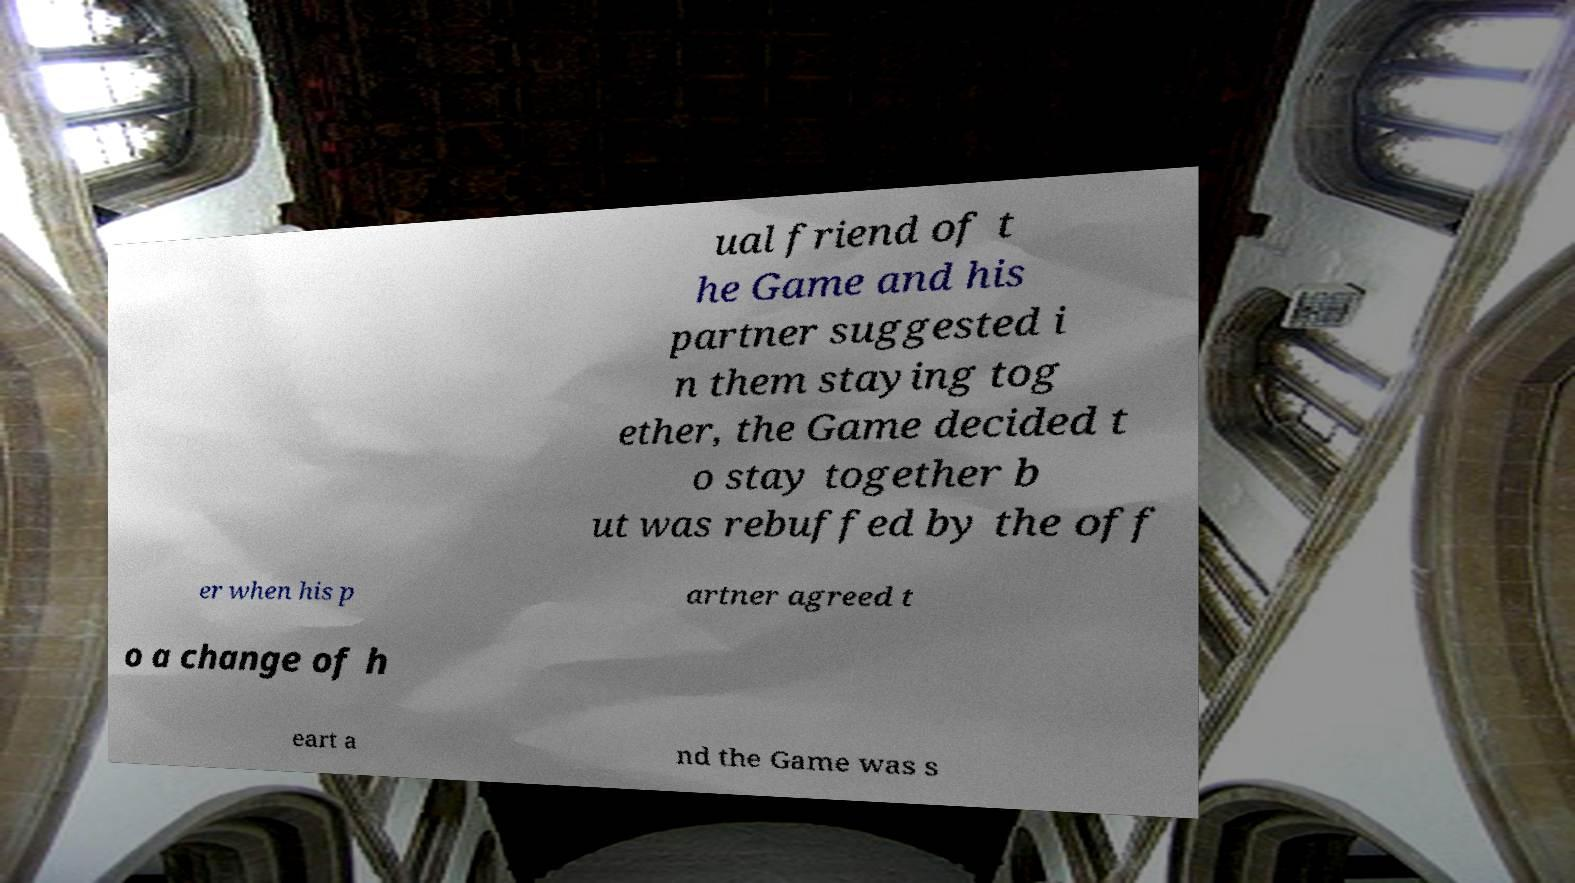For documentation purposes, I need the text within this image transcribed. Could you provide that? ual friend of t he Game and his partner suggested i n them staying tog ether, the Game decided t o stay together b ut was rebuffed by the off er when his p artner agreed t o a change of h eart a nd the Game was s 